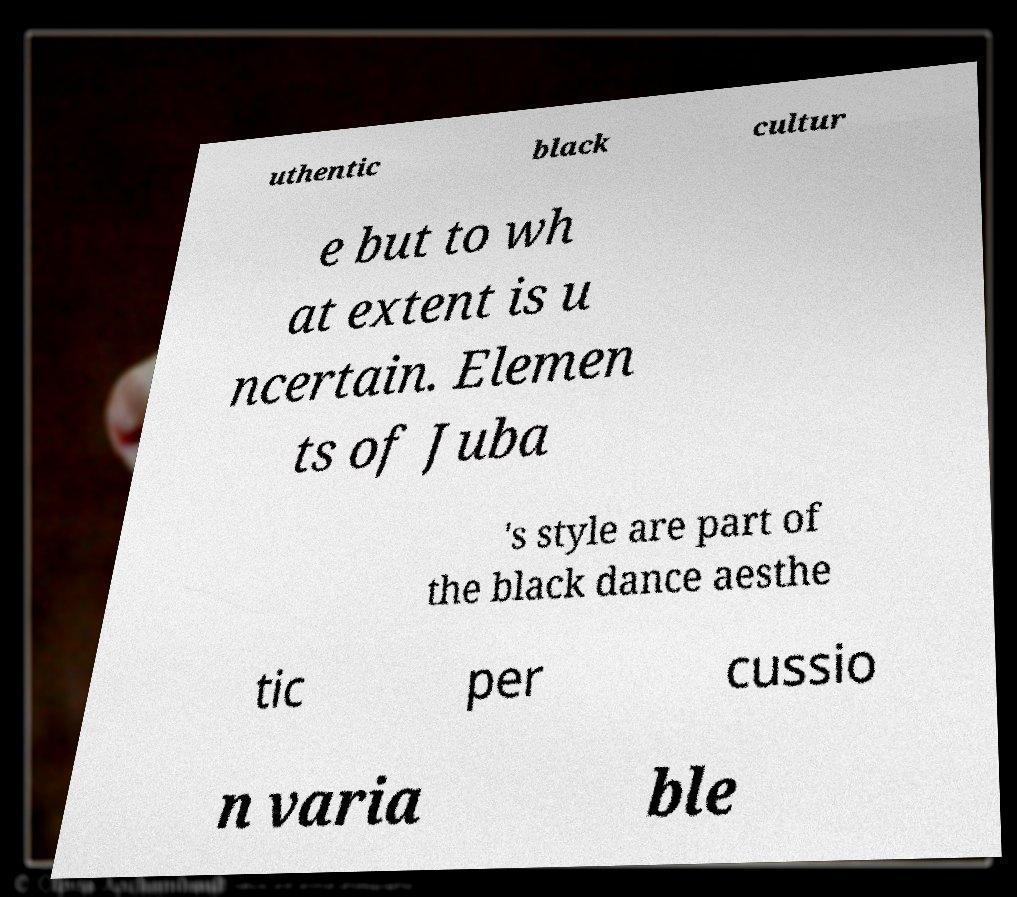For documentation purposes, I need the text within this image transcribed. Could you provide that? uthentic black cultur e but to wh at extent is u ncertain. Elemen ts of Juba 's style are part of the black dance aesthe tic per cussio n varia ble 